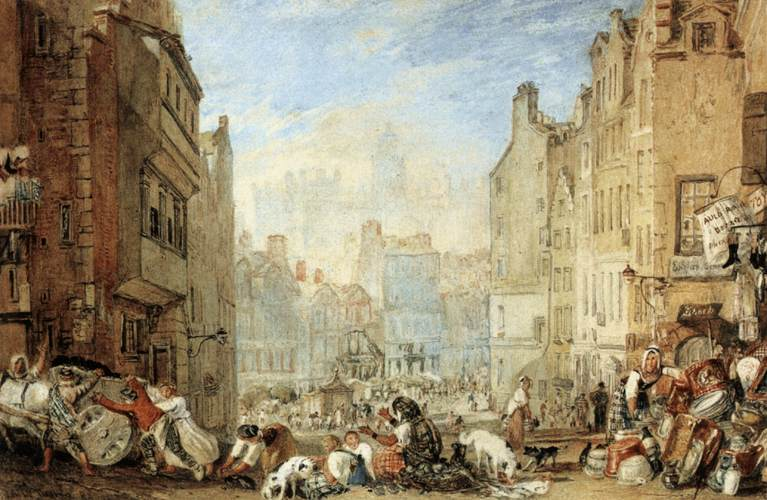What time period does this image likely depict, and can you point out any visual cues that suggest this? The image likely depicts the late 18th or early 19th century, as suggested by several visual cues. One significant cue is the style of clothing worn by the figures; long dresses and prominent bonnets for women, and breeches for men, are typical of this era. The architecture, with its detailed façade elements and smaller paned windows, also reflects the styles common in European cities during those centuries. 